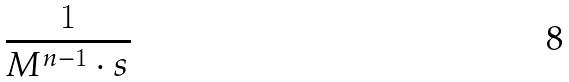Convert formula to latex. <formula><loc_0><loc_0><loc_500><loc_500>\frac { 1 } { M ^ { n - 1 } \cdot s }</formula> 